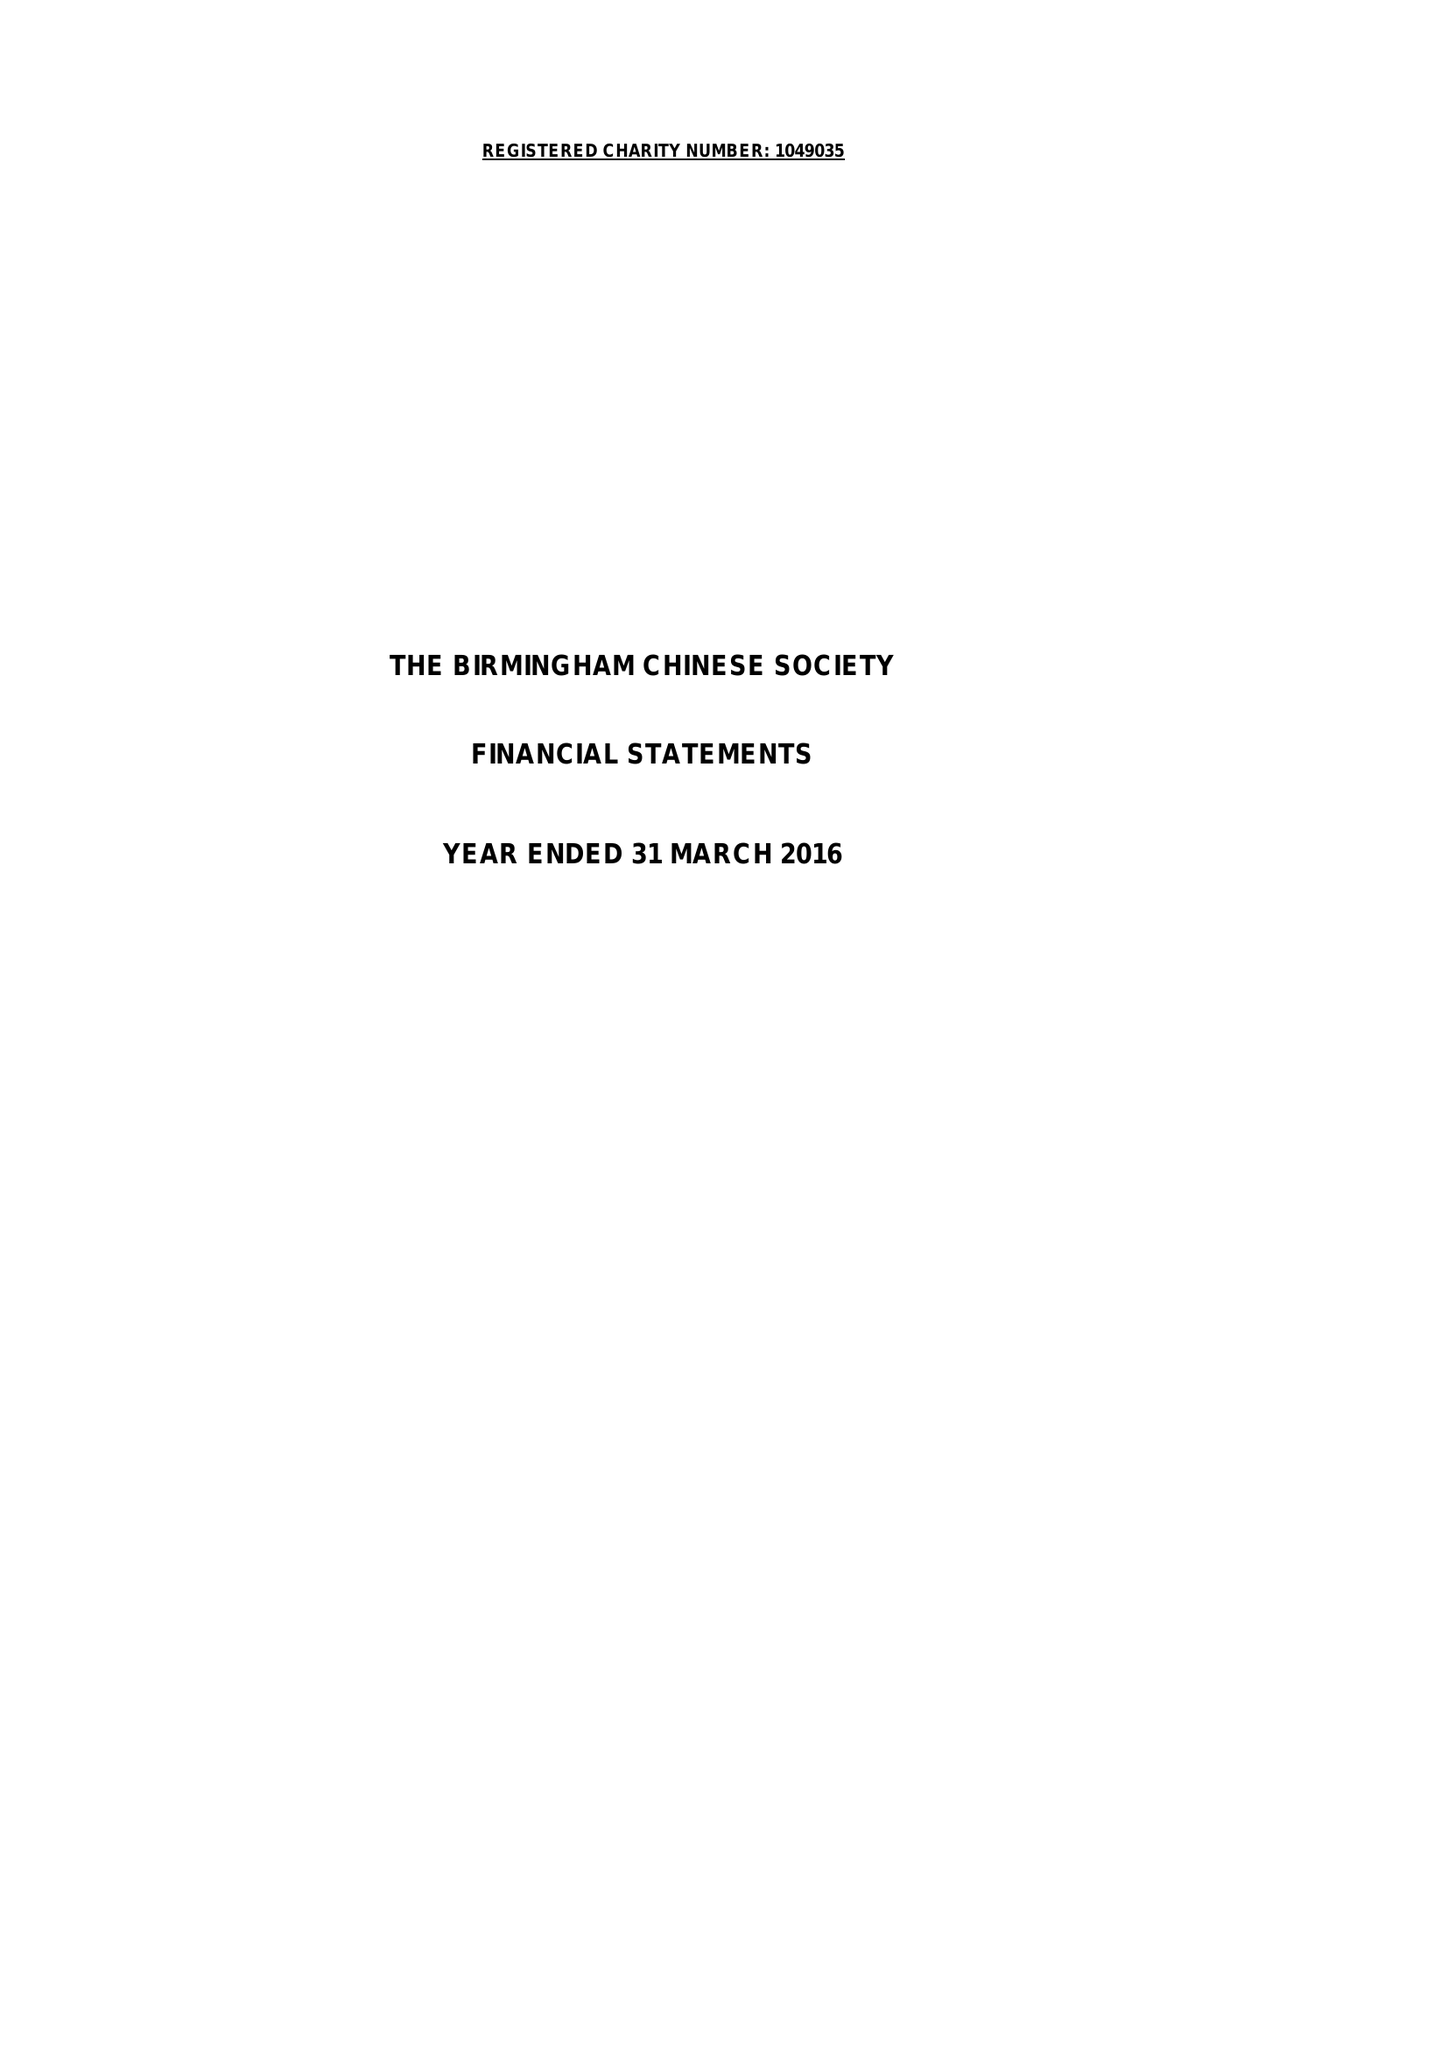What is the value for the address__street_line?
Answer the question using a single word or phrase. 11 ALLCOCK STREET 